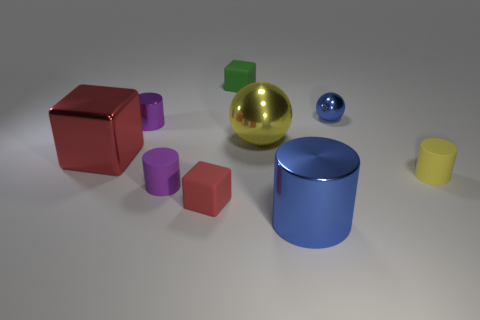There is a cylinder that is on the right side of the yellow metal thing and to the left of the yellow rubber thing; how big is it?
Your response must be concise. Large. What is the size of the rubber cylinder that is on the left side of the cylinder on the right side of the large shiny object right of the yellow metallic thing?
Make the answer very short. Small. How many other objects are there of the same color as the tiny shiny ball?
Your response must be concise. 1. There is a rubber thing on the right side of the green block; is its color the same as the large sphere?
Your answer should be compact. Yes. How many objects are purple rubber cylinders or brown metal objects?
Offer a very short reply. 1. What color is the small matte cylinder left of the small green object?
Your response must be concise. Purple. Is the number of small rubber cubes to the left of the red metallic thing less than the number of tiny matte spheres?
Your response must be concise. No. What size is the object that is the same color as the large ball?
Provide a short and direct response. Small. Is the big blue object made of the same material as the blue sphere?
Offer a terse response. Yes. How many things are red objects that are behind the small yellow rubber cylinder or tiny matte things on the left side of the big yellow thing?
Your answer should be compact. 4. 